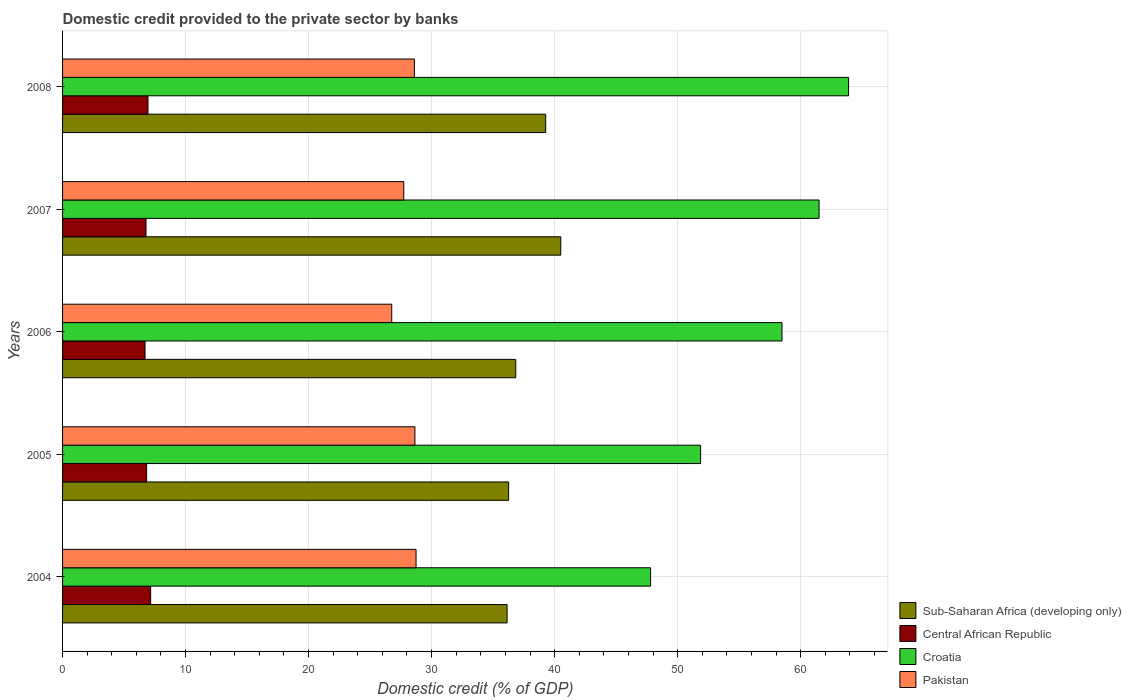How many different coloured bars are there?
Make the answer very short. 4. Are the number of bars per tick equal to the number of legend labels?
Your answer should be very brief. Yes. How many bars are there on the 3rd tick from the top?
Make the answer very short. 4. How many bars are there on the 2nd tick from the bottom?
Your response must be concise. 4. In how many cases, is the number of bars for a given year not equal to the number of legend labels?
Offer a terse response. 0. What is the domestic credit provided to the private sector by banks in Sub-Saharan Africa (developing only) in 2004?
Your answer should be compact. 36.14. Across all years, what is the maximum domestic credit provided to the private sector by banks in Pakistan?
Provide a succinct answer. 28.74. Across all years, what is the minimum domestic credit provided to the private sector by banks in Pakistan?
Offer a very short reply. 26.76. In which year was the domestic credit provided to the private sector by banks in Pakistan maximum?
Make the answer very short. 2004. What is the total domestic credit provided to the private sector by banks in Pakistan in the graph?
Ensure brevity in your answer.  140.48. What is the difference between the domestic credit provided to the private sector by banks in Sub-Saharan Africa (developing only) in 2005 and that in 2007?
Keep it short and to the point. -4.24. What is the difference between the domestic credit provided to the private sector by banks in Croatia in 2005 and the domestic credit provided to the private sector by banks in Central African Republic in 2007?
Provide a succinct answer. 45.09. What is the average domestic credit provided to the private sector by banks in Croatia per year?
Your answer should be compact. 56.71. In the year 2005, what is the difference between the domestic credit provided to the private sector by banks in Sub-Saharan Africa (developing only) and domestic credit provided to the private sector by banks in Central African Republic?
Your response must be concise. 29.43. What is the ratio of the domestic credit provided to the private sector by banks in Central African Republic in 2005 to that in 2006?
Your response must be concise. 1.02. Is the difference between the domestic credit provided to the private sector by banks in Sub-Saharan Africa (developing only) in 2005 and 2007 greater than the difference between the domestic credit provided to the private sector by banks in Central African Republic in 2005 and 2007?
Give a very brief answer. No. What is the difference between the highest and the second highest domestic credit provided to the private sector by banks in Central African Republic?
Ensure brevity in your answer.  0.22. What is the difference between the highest and the lowest domestic credit provided to the private sector by banks in Croatia?
Ensure brevity in your answer.  16.1. In how many years, is the domestic credit provided to the private sector by banks in Croatia greater than the average domestic credit provided to the private sector by banks in Croatia taken over all years?
Provide a short and direct response. 3. Is the sum of the domestic credit provided to the private sector by banks in Central African Republic in 2005 and 2008 greater than the maximum domestic credit provided to the private sector by banks in Croatia across all years?
Keep it short and to the point. No. Is it the case that in every year, the sum of the domestic credit provided to the private sector by banks in Pakistan and domestic credit provided to the private sector by banks in Central African Republic is greater than the sum of domestic credit provided to the private sector by banks in Croatia and domestic credit provided to the private sector by banks in Sub-Saharan Africa (developing only)?
Provide a succinct answer. Yes. What does the 1st bar from the top in 2008 represents?
Make the answer very short. Pakistan. What does the 4th bar from the bottom in 2006 represents?
Your answer should be very brief. Pakistan. Is it the case that in every year, the sum of the domestic credit provided to the private sector by banks in Sub-Saharan Africa (developing only) and domestic credit provided to the private sector by banks in Pakistan is greater than the domestic credit provided to the private sector by banks in Central African Republic?
Your answer should be compact. Yes. What is the difference between two consecutive major ticks on the X-axis?
Your answer should be compact. 10. Are the values on the major ticks of X-axis written in scientific E-notation?
Provide a succinct answer. No. Where does the legend appear in the graph?
Give a very brief answer. Bottom right. How are the legend labels stacked?
Ensure brevity in your answer.  Vertical. What is the title of the graph?
Your response must be concise. Domestic credit provided to the private sector by banks. What is the label or title of the X-axis?
Give a very brief answer. Domestic credit (% of GDP). What is the label or title of the Y-axis?
Ensure brevity in your answer.  Years. What is the Domestic credit (% of GDP) in Sub-Saharan Africa (developing only) in 2004?
Your answer should be compact. 36.14. What is the Domestic credit (% of GDP) in Central African Republic in 2004?
Your answer should be very brief. 7.16. What is the Domestic credit (% of GDP) of Croatia in 2004?
Ensure brevity in your answer.  47.8. What is the Domestic credit (% of GDP) in Pakistan in 2004?
Give a very brief answer. 28.74. What is the Domestic credit (% of GDP) of Sub-Saharan Africa (developing only) in 2005?
Your answer should be very brief. 36.26. What is the Domestic credit (% of GDP) of Central African Republic in 2005?
Make the answer very short. 6.83. What is the Domestic credit (% of GDP) of Croatia in 2005?
Offer a terse response. 51.87. What is the Domestic credit (% of GDP) in Pakistan in 2005?
Offer a terse response. 28.65. What is the Domestic credit (% of GDP) of Sub-Saharan Africa (developing only) in 2006?
Provide a succinct answer. 36.84. What is the Domestic credit (% of GDP) of Central African Republic in 2006?
Your answer should be compact. 6.71. What is the Domestic credit (% of GDP) in Croatia in 2006?
Offer a terse response. 58.49. What is the Domestic credit (% of GDP) in Pakistan in 2006?
Provide a short and direct response. 26.76. What is the Domestic credit (% of GDP) in Sub-Saharan Africa (developing only) in 2007?
Offer a very short reply. 40.5. What is the Domestic credit (% of GDP) of Central African Republic in 2007?
Keep it short and to the point. 6.78. What is the Domestic credit (% of GDP) in Croatia in 2007?
Offer a terse response. 61.5. What is the Domestic credit (% of GDP) of Pakistan in 2007?
Offer a very short reply. 27.74. What is the Domestic credit (% of GDP) in Sub-Saharan Africa (developing only) in 2008?
Provide a short and direct response. 39.28. What is the Domestic credit (% of GDP) of Central African Republic in 2008?
Ensure brevity in your answer.  6.94. What is the Domestic credit (% of GDP) in Croatia in 2008?
Give a very brief answer. 63.9. What is the Domestic credit (% of GDP) of Pakistan in 2008?
Provide a short and direct response. 28.6. Across all years, what is the maximum Domestic credit (% of GDP) of Sub-Saharan Africa (developing only)?
Ensure brevity in your answer.  40.5. Across all years, what is the maximum Domestic credit (% of GDP) of Central African Republic?
Offer a terse response. 7.16. Across all years, what is the maximum Domestic credit (% of GDP) of Croatia?
Ensure brevity in your answer.  63.9. Across all years, what is the maximum Domestic credit (% of GDP) of Pakistan?
Provide a succinct answer. 28.74. Across all years, what is the minimum Domestic credit (% of GDP) in Sub-Saharan Africa (developing only)?
Offer a terse response. 36.14. Across all years, what is the minimum Domestic credit (% of GDP) of Central African Republic?
Your answer should be very brief. 6.71. Across all years, what is the minimum Domestic credit (% of GDP) in Croatia?
Keep it short and to the point. 47.8. Across all years, what is the minimum Domestic credit (% of GDP) in Pakistan?
Offer a terse response. 26.76. What is the total Domestic credit (% of GDP) of Sub-Saharan Africa (developing only) in the graph?
Offer a terse response. 189.02. What is the total Domestic credit (% of GDP) of Central African Republic in the graph?
Make the answer very short. 34.43. What is the total Domestic credit (% of GDP) in Croatia in the graph?
Your answer should be compact. 283.56. What is the total Domestic credit (% of GDP) in Pakistan in the graph?
Your answer should be very brief. 140.48. What is the difference between the Domestic credit (% of GDP) of Sub-Saharan Africa (developing only) in 2004 and that in 2005?
Offer a terse response. -0.12. What is the difference between the Domestic credit (% of GDP) in Central African Republic in 2004 and that in 2005?
Give a very brief answer. 0.33. What is the difference between the Domestic credit (% of GDP) of Croatia in 2004 and that in 2005?
Provide a succinct answer. -4.06. What is the difference between the Domestic credit (% of GDP) of Pakistan in 2004 and that in 2005?
Your answer should be compact. 0.09. What is the difference between the Domestic credit (% of GDP) in Sub-Saharan Africa (developing only) in 2004 and that in 2006?
Your answer should be compact. -0.7. What is the difference between the Domestic credit (% of GDP) of Central African Republic in 2004 and that in 2006?
Make the answer very short. 0.45. What is the difference between the Domestic credit (% of GDP) in Croatia in 2004 and that in 2006?
Provide a short and direct response. -10.68. What is the difference between the Domestic credit (% of GDP) in Pakistan in 2004 and that in 2006?
Make the answer very short. 1.98. What is the difference between the Domestic credit (% of GDP) in Sub-Saharan Africa (developing only) in 2004 and that in 2007?
Your response must be concise. -4.36. What is the difference between the Domestic credit (% of GDP) in Central African Republic in 2004 and that in 2007?
Your answer should be very brief. 0.38. What is the difference between the Domestic credit (% of GDP) of Croatia in 2004 and that in 2007?
Offer a very short reply. -13.7. What is the difference between the Domestic credit (% of GDP) in Sub-Saharan Africa (developing only) in 2004 and that in 2008?
Your answer should be very brief. -3.14. What is the difference between the Domestic credit (% of GDP) of Central African Republic in 2004 and that in 2008?
Your answer should be compact. 0.22. What is the difference between the Domestic credit (% of GDP) of Croatia in 2004 and that in 2008?
Provide a succinct answer. -16.09. What is the difference between the Domestic credit (% of GDP) of Pakistan in 2004 and that in 2008?
Give a very brief answer. 0.13. What is the difference between the Domestic credit (% of GDP) of Sub-Saharan Africa (developing only) in 2005 and that in 2006?
Give a very brief answer. -0.58. What is the difference between the Domestic credit (% of GDP) in Central African Republic in 2005 and that in 2006?
Give a very brief answer. 0.13. What is the difference between the Domestic credit (% of GDP) in Croatia in 2005 and that in 2006?
Provide a succinct answer. -6.62. What is the difference between the Domestic credit (% of GDP) in Pakistan in 2005 and that in 2006?
Offer a very short reply. 1.89. What is the difference between the Domestic credit (% of GDP) of Sub-Saharan Africa (developing only) in 2005 and that in 2007?
Offer a terse response. -4.24. What is the difference between the Domestic credit (% of GDP) of Central African Republic in 2005 and that in 2007?
Give a very brief answer. 0.05. What is the difference between the Domestic credit (% of GDP) of Croatia in 2005 and that in 2007?
Provide a succinct answer. -9.63. What is the difference between the Domestic credit (% of GDP) of Pakistan in 2005 and that in 2007?
Make the answer very short. 0.91. What is the difference between the Domestic credit (% of GDP) of Sub-Saharan Africa (developing only) in 2005 and that in 2008?
Your response must be concise. -3.01. What is the difference between the Domestic credit (% of GDP) in Central African Republic in 2005 and that in 2008?
Give a very brief answer. -0.11. What is the difference between the Domestic credit (% of GDP) of Croatia in 2005 and that in 2008?
Your answer should be compact. -12.03. What is the difference between the Domestic credit (% of GDP) of Pakistan in 2005 and that in 2008?
Your response must be concise. 0.04. What is the difference between the Domestic credit (% of GDP) in Sub-Saharan Africa (developing only) in 2006 and that in 2007?
Offer a very short reply. -3.66. What is the difference between the Domestic credit (% of GDP) of Central African Republic in 2006 and that in 2007?
Offer a terse response. -0.08. What is the difference between the Domestic credit (% of GDP) of Croatia in 2006 and that in 2007?
Give a very brief answer. -3.01. What is the difference between the Domestic credit (% of GDP) in Pakistan in 2006 and that in 2007?
Keep it short and to the point. -0.98. What is the difference between the Domestic credit (% of GDP) in Sub-Saharan Africa (developing only) in 2006 and that in 2008?
Your answer should be compact. -2.43. What is the difference between the Domestic credit (% of GDP) of Central African Republic in 2006 and that in 2008?
Offer a very short reply. -0.24. What is the difference between the Domestic credit (% of GDP) in Croatia in 2006 and that in 2008?
Your answer should be very brief. -5.41. What is the difference between the Domestic credit (% of GDP) in Pakistan in 2006 and that in 2008?
Provide a short and direct response. -1.84. What is the difference between the Domestic credit (% of GDP) of Sub-Saharan Africa (developing only) in 2007 and that in 2008?
Provide a short and direct response. 1.23. What is the difference between the Domestic credit (% of GDP) in Central African Republic in 2007 and that in 2008?
Provide a succinct answer. -0.16. What is the difference between the Domestic credit (% of GDP) of Croatia in 2007 and that in 2008?
Provide a short and direct response. -2.4. What is the difference between the Domestic credit (% of GDP) of Pakistan in 2007 and that in 2008?
Make the answer very short. -0.87. What is the difference between the Domestic credit (% of GDP) in Sub-Saharan Africa (developing only) in 2004 and the Domestic credit (% of GDP) in Central African Republic in 2005?
Offer a very short reply. 29.31. What is the difference between the Domestic credit (% of GDP) in Sub-Saharan Africa (developing only) in 2004 and the Domestic credit (% of GDP) in Croatia in 2005?
Your answer should be very brief. -15.73. What is the difference between the Domestic credit (% of GDP) in Sub-Saharan Africa (developing only) in 2004 and the Domestic credit (% of GDP) in Pakistan in 2005?
Offer a terse response. 7.49. What is the difference between the Domestic credit (% of GDP) of Central African Republic in 2004 and the Domestic credit (% of GDP) of Croatia in 2005?
Ensure brevity in your answer.  -44.71. What is the difference between the Domestic credit (% of GDP) of Central African Republic in 2004 and the Domestic credit (% of GDP) of Pakistan in 2005?
Make the answer very short. -21.48. What is the difference between the Domestic credit (% of GDP) in Croatia in 2004 and the Domestic credit (% of GDP) in Pakistan in 2005?
Provide a short and direct response. 19.16. What is the difference between the Domestic credit (% of GDP) in Sub-Saharan Africa (developing only) in 2004 and the Domestic credit (% of GDP) in Central African Republic in 2006?
Your answer should be compact. 29.43. What is the difference between the Domestic credit (% of GDP) in Sub-Saharan Africa (developing only) in 2004 and the Domestic credit (% of GDP) in Croatia in 2006?
Your response must be concise. -22.35. What is the difference between the Domestic credit (% of GDP) in Sub-Saharan Africa (developing only) in 2004 and the Domestic credit (% of GDP) in Pakistan in 2006?
Provide a short and direct response. 9.38. What is the difference between the Domestic credit (% of GDP) in Central African Republic in 2004 and the Domestic credit (% of GDP) in Croatia in 2006?
Ensure brevity in your answer.  -51.33. What is the difference between the Domestic credit (% of GDP) in Central African Republic in 2004 and the Domestic credit (% of GDP) in Pakistan in 2006?
Provide a short and direct response. -19.6. What is the difference between the Domestic credit (% of GDP) of Croatia in 2004 and the Domestic credit (% of GDP) of Pakistan in 2006?
Provide a short and direct response. 21.04. What is the difference between the Domestic credit (% of GDP) of Sub-Saharan Africa (developing only) in 2004 and the Domestic credit (% of GDP) of Central African Republic in 2007?
Offer a very short reply. 29.36. What is the difference between the Domestic credit (% of GDP) in Sub-Saharan Africa (developing only) in 2004 and the Domestic credit (% of GDP) in Croatia in 2007?
Your answer should be compact. -25.36. What is the difference between the Domestic credit (% of GDP) of Sub-Saharan Africa (developing only) in 2004 and the Domestic credit (% of GDP) of Pakistan in 2007?
Your answer should be very brief. 8.4. What is the difference between the Domestic credit (% of GDP) of Central African Republic in 2004 and the Domestic credit (% of GDP) of Croatia in 2007?
Keep it short and to the point. -54.34. What is the difference between the Domestic credit (% of GDP) in Central African Republic in 2004 and the Domestic credit (% of GDP) in Pakistan in 2007?
Your response must be concise. -20.58. What is the difference between the Domestic credit (% of GDP) in Croatia in 2004 and the Domestic credit (% of GDP) in Pakistan in 2007?
Your answer should be very brief. 20.07. What is the difference between the Domestic credit (% of GDP) in Sub-Saharan Africa (developing only) in 2004 and the Domestic credit (% of GDP) in Central African Republic in 2008?
Ensure brevity in your answer.  29.19. What is the difference between the Domestic credit (% of GDP) in Sub-Saharan Africa (developing only) in 2004 and the Domestic credit (% of GDP) in Croatia in 2008?
Keep it short and to the point. -27.76. What is the difference between the Domestic credit (% of GDP) in Sub-Saharan Africa (developing only) in 2004 and the Domestic credit (% of GDP) in Pakistan in 2008?
Provide a succinct answer. 7.54. What is the difference between the Domestic credit (% of GDP) in Central African Republic in 2004 and the Domestic credit (% of GDP) in Croatia in 2008?
Provide a short and direct response. -56.74. What is the difference between the Domestic credit (% of GDP) in Central African Republic in 2004 and the Domestic credit (% of GDP) in Pakistan in 2008?
Offer a very short reply. -21.44. What is the difference between the Domestic credit (% of GDP) of Croatia in 2004 and the Domestic credit (% of GDP) of Pakistan in 2008?
Offer a terse response. 19.2. What is the difference between the Domestic credit (% of GDP) of Sub-Saharan Africa (developing only) in 2005 and the Domestic credit (% of GDP) of Central African Republic in 2006?
Give a very brief answer. 29.56. What is the difference between the Domestic credit (% of GDP) in Sub-Saharan Africa (developing only) in 2005 and the Domestic credit (% of GDP) in Croatia in 2006?
Ensure brevity in your answer.  -22.22. What is the difference between the Domestic credit (% of GDP) of Sub-Saharan Africa (developing only) in 2005 and the Domestic credit (% of GDP) of Pakistan in 2006?
Your answer should be very brief. 9.5. What is the difference between the Domestic credit (% of GDP) of Central African Republic in 2005 and the Domestic credit (% of GDP) of Croatia in 2006?
Give a very brief answer. -51.65. What is the difference between the Domestic credit (% of GDP) in Central African Republic in 2005 and the Domestic credit (% of GDP) in Pakistan in 2006?
Your answer should be very brief. -19.93. What is the difference between the Domestic credit (% of GDP) in Croatia in 2005 and the Domestic credit (% of GDP) in Pakistan in 2006?
Make the answer very short. 25.11. What is the difference between the Domestic credit (% of GDP) of Sub-Saharan Africa (developing only) in 2005 and the Domestic credit (% of GDP) of Central African Republic in 2007?
Offer a terse response. 29.48. What is the difference between the Domestic credit (% of GDP) in Sub-Saharan Africa (developing only) in 2005 and the Domestic credit (% of GDP) in Croatia in 2007?
Ensure brevity in your answer.  -25.24. What is the difference between the Domestic credit (% of GDP) in Sub-Saharan Africa (developing only) in 2005 and the Domestic credit (% of GDP) in Pakistan in 2007?
Your answer should be compact. 8.53. What is the difference between the Domestic credit (% of GDP) in Central African Republic in 2005 and the Domestic credit (% of GDP) in Croatia in 2007?
Give a very brief answer. -54.67. What is the difference between the Domestic credit (% of GDP) of Central African Republic in 2005 and the Domestic credit (% of GDP) of Pakistan in 2007?
Make the answer very short. -20.9. What is the difference between the Domestic credit (% of GDP) in Croatia in 2005 and the Domestic credit (% of GDP) in Pakistan in 2007?
Make the answer very short. 24.13. What is the difference between the Domestic credit (% of GDP) of Sub-Saharan Africa (developing only) in 2005 and the Domestic credit (% of GDP) of Central African Republic in 2008?
Ensure brevity in your answer.  29.32. What is the difference between the Domestic credit (% of GDP) of Sub-Saharan Africa (developing only) in 2005 and the Domestic credit (% of GDP) of Croatia in 2008?
Give a very brief answer. -27.64. What is the difference between the Domestic credit (% of GDP) of Sub-Saharan Africa (developing only) in 2005 and the Domestic credit (% of GDP) of Pakistan in 2008?
Your answer should be compact. 7.66. What is the difference between the Domestic credit (% of GDP) of Central African Republic in 2005 and the Domestic credit (% of GDP) of Croatia in 2008?
Offer a terse response. -57.07. What is the difference between the Domestic credit (% of GDP) in Central African Republic in 2005 and the Domestic credit (% of GDP) in Pakistan in 2008?
Your answer should be very brief. -21.77. What is the difference between the Domestic credit (% of GDP) of Croatia in 2005 and the Domestic credit (% of GDP) of Pakistan in 2008?
Keep it short and to the point. 23.27. What is the difference between the Domestic credit (% of GDP) in Sub-Saharan Africa (developing only) in 2006 and the Domestic credit (% of GDP) in Central African Republic in 2007?
Ensure brevity in your answer.  30.06. What is the difference between the Domestic credit (% of GDP) of Sub-Saharan Africa (developing only) in 2006 and the Domestic credit (% of GDP) of Croatia in 2007?
Your answer should be compact. -24.66. What is the difference between the Domestic credit (% of GDP) of Sub-Saharan Africa (developing only) in 2006 and the Domestic credit (% of GDP) of Pakistan in 2007?
Ensure brevity in your answer.  9.11. What is the difference between the Domestic credit (% of GDP) of Central African Republic in 2006 and the Domestic credit (% of GDP) of Croatia in 2007?
Your answer should be very brief. -54.79. What is the difference between the Domestic credit (% of GDP) in Central African Republic in 2006 and the Domestic credit (% of GDP) in Pakistan in 2007?
Your answer should be very brief. -21.03. What is the difference between the Domestic credit (% of GDP) of Croatia in 2006 and the Domestic credit (% of GDP) of Pakistan in 2007?
Ensure brevity in your answer.  30.75. What is the difference between the Domestic credit (% of GDP) in Sub-Saharan Africa (developing only) in 2006 and the Domestic credit (% of GDP) in Central African Republic in 2008?
Provide a succinct answer. 29.9. What is the difference between the Domestic credit (% of GDP) of Sub-Saharan Africa (developing only) in 2006 and the Domestic credit (% of GDP) of Croatia in 2008?
Your answer should be compact. -27.06. What is the difference between the Domestic credit (% of GDP) in Sub-Saharan Africa (developing only) in 2006 and the Domestic credit (% of GDP) in Pakistan in 2008?
Keep it short and to the point. 8.24. What is the difference between the Domestic credit (% of GDP) of Central African Republic in 2006 and the Domestic credit (% of GDP) of Croatia in 2008?
Your response must be concise. -57.19. What is the difference between the Domestic credit (% of GDP) in Central African Republic in 2006 and the Domestic credit (% of GDP) in Pakistan in 2008?
Ensure brevity in your answer.  -21.9. What is the difference between the Domestic credit (% of GDP) in Croatia in 2006 and the Domestic credit (% of GDP) in Pakistan in 2008?
Offer a terse response. 29.88. What is the difference between the Domestic credit (% of GDP) of Sub-Saharan Africa (developing only) in 2007 and the Domestic credit (% of GDP) of Central African Republic in 2008?
Provide a succinct answer. 33.56. What is the difference between the Domestic credit (% of GDP) in Sub-Saharan Africa (developing only) in 2007 and the Domestic credit (% of GDP) in Croatia in 2008?
Make the answer very short. -23.4. What is the difference between the Domestic credit (% of GDP) in Sub-Saharan Africa (developing only) in 2007 and the Domestic credit (% of GDP) in Pakistan in 2008?
Offer a terse response. 11.9. What is the difference between the Domestic credit (% of GDP) in Central African Republic in 2007 and the Domestic credit (% of GDP) in Croatia in 2008?
Offer a very short reply. -57.12. What is the difference between the Domestic credit (% of GDP) in Central African Republic in 2007 and the Domestic credit (% of GDP) in Pakistan in 2008?
Ensure brevity in your answer.  -21.82. What is the difference between the Domestic credit (% of GDP) in Croatia in 2007 and the Domestic credit (% of GDP) in Pakistan in 2008?
Provide a short and direct response. 32.9. What is the average Domestic credit (% of GDP) in Sub-Saharan Africa (developing only) per year?
Offer a terse response. 37.8. What is the average Domestic credit (% of GDP) in Central African Republic per year?
Give a very brief answer. 6.89. What is the average Domestic credit (% of GDP) of Croatia per year?
Ensure brevity in your answer.  56.71. What is the average Domestic credit (% of GDP) of Pakistan per year?
Provide a short and direct response. 28.1. In the year 2004, what is the difference between the Domestic credit (% of GDP) in Sub-Saharan Africa (developing only) and Domestic credit (% of GDP) in Central African Republic?
Provide a succinct answer. 28.98. In the year 2004, what is the difference between the Domestic credit (% of GDP) in Sub-Saharan Africa (developing only) and Domestic credit (% of GDP) in Croatia?
Provide a short and direct response. -11.67. In the year 2004, what is the difference between the Domestic credit (% of GDP) of Sub-Saharan Africa (developing only) and Domestic credit (% of GDP) of Pakistan?
Provide a succinct answer. 7.4. In the year 2004, what is the difference between the Domestic credit (% of GDP) in Central African Republic and Domestic credit (% of GDP) in Croatia?
Your answer should be compact. -40.64. In the year 2004, what is the difference between the Domestic credit (% of GDP) of Central African Republic and Domestic credit (% of GDP) of Pakistan?
Keep it short and to the point. -21.58. In the year 2004, what is the difference between the Domestic credit (% of GDP) of Croatia and Domestic credit (% of GDP) of Pakistan?
Your response must be concise. 19.07. In the year 2005, what is the difference between the Domestic credit (% of GDP) of Sub-Saharan Africa (developing only) and Domestic credit (% of GDP) of Central African Republic?
Your answer should be compact. 29.43. In the year 2005, what is the difference between the Domestic credit (% of GDP) in Sub-Saharan Africa (developing only) and Domestic credit (% of GDP) in Croatia?
Offer a terse response. -15.61. In the year 2005, what is the difference between the Domestic credit (% of GDP) of Sub-Saharan Africa (developing only) and Domestic credit (% of GDP) of Pakistan?
Offer a terse response. 7.62. In the year 2005, what is the difference between the Domestic credit (% of GDP) of Central African Republic and Domestic credit (% of GDP) of Croatia?
Your answer should be compact. -45.04. In the year 2005, what is the difference between the Domestic credit (% of GDP) of Central African Republic and Domestic credit (% of GDP) of Pakistan?
Provide a succinct answer. -21.81. In the year 2005, what is the difference between the Domestic credit (% of GDP) in Croatia and Domestic credit (% of GDP) in Pakistan?
Your response must be concise. 23.22. In the year 2006, what is the difference between the Domestic credit (% of GDP) in Sub-Saharan Africa (developing only) and Domestic credit (% of GDP) in Central African Republic?
Make the answer very short. 30.14. In the year 2006, what is the difference between the Domestic credit (% of GDP) in Sub-Saharan Africa (developing only) and Domestic credit (% of GDP) in Croatia?
Your response must be concise. -21.64. In the year 2006, what is the difference between the Domestic credit (% of GDP) in Sub-Saharan Africa (developing only) and Domestic credit (% of GDP) in Pakistan?
Your answer should be very brief. 10.08. In the year 2006, what is the difference between the Domestic credit (% of GDP) of Central African Republic and Domestic credit (% of GDP) of Croatia?
Offer a very short reply. -51.78. In the year 2006, what is the difference between the Domestic credit (% of GDP) of Central African Republic and Domestic credit (% of GDP) of Pakistan?
Keep it short and to the point. -20.05. In the year 2006, what is the difference between the Domestic credit (% of GDP) of Croatia and Domestic credit (% of GDP) of Pakistan?
Provide a succinct answer. 31.73. In the year 2007, what is the difference between the Domestic credit (% of GDP) in Sub-Saharan Africa (developing only) and Domestic credit (% of GDP) in Central African Republic?
Provide a short and direct response. 33.72. In the year 2007, what is the difference between the Domestic credit (% of GDP) in Sub-Saharan Africa (developing only) and Domestic credit (% of GDP) in Croatia?
Offer a terse response. -21. In the year 2007, what is the difference between the Domestic credit (% of GDP) in Sub-Saharan Africa (developing only) and Domestic credit (% of GDP) in Pakistan?
Make the answer very short. 12.77. In the year 2007, what is the difference between the Domestic credit (% of GDP) in Central African Republic and Domestic credit (% of GDP) in Croatia?
Your response must be concise. -54.72. In the year 2007, what is the difference between the Domestic credit (% of GDP) of Central African Republic and Domestic credit (% of GDP) of Pakistan?
Keep it short and to the point. -20.95. In the year 2007, what is the difference between the Domestic credit (% of GDP) of Croatia and Domestic credit (% of GDP) of Pakistan?
Provide a short and direct response. 33.76. In the year 2008, what is the difference between the Domestic credit (% of GDP) in Sub-Saharan Africa (developing only) and Domestic credit (% of GDP) in Central African Republic?
Provide a succinct answer. 32.33. In the year 2008, what is the difference between the Domestic credit (% of GDP) in Sub-Saharan Africa (developing only) and Domestic credit (% of GDP) in Croatia?
Give a very brief answer. -24.62. In the year 2008, what is the difference between the Domestic credit (% of GDP) in Sub-Saharan Africa (developing only) and Domestic credit (% of GDP) in Pakistan?
Give a very brief answer. 10.67. In the year 2008, what is the difference between the Domestic credit (% of GDP) in Central African Republic and Domestic credit (% of GDP) in Croatia?
Your response must be concise. -56.96. In the year 2008, what is the difference between the Domestic credit (% of GDP) in Central African Republic and Domestic credit (% of GDP) in Pakistan?
Ensure brevity in your answer.  -21.66. In the year 2008, what is the difference between the Domestic credit (% of GDP) in Croatia and Domestic credit (% of GDP) in Pakistan?
Offer a terse response. 35.3. What is the ratio of the Domestic credit (% of GDP) in Central African Republic in 2004 to that in 2005?
Keep it short and to the point. 1.05. What is the ratio of the Domestic credit (% of GDP) in Croatia in 2004 to that in 2005?
Your answer should be compact. 0.92. What is the ratio of the Domestic credit (% of GDP) in Pakistan in 2004 to that in 2005?
Offer a very short reply. 1. What is the ratio of the Domestic credit (% of GDP) of Sub-Saharan Africa (developing only) in 2004 to that in 2006?
Provide a succinct answer. 0.98. What is the ratio of the Domestic credit (% of GDP) of Central African Republic in 2004 to that in 2006?
Provide a succinct answer. 1.07. What is the ratio of the Domestic credit (% of GDP) in Croatia in 2004 to that in 2006?
Your answer should be very brief. 0.82. What is the ratio of the Domestic credit (% of GDP) in Pakistan in 2004 to that in 2006?
Your response must be concise. 1.07. What is the ratio of the Domestic credit (% of GDP) in Sub-Saharan Africa (developing only) in 2004 to that in 2007?
Give a very brief answer. 0.89. What is the ratio of the Domestic credit (% of GDP) in Central African Republic in 2004 to that in 2007?
Give a very brief answer. 1.06. What is the ratio of the Domestic credit (% of GDP) of Croatia in 2004 to that in 2007?
Keep it short and to the point. 0.78. What is the ratio of the Domestic credit (% of GDP) in Pakistan in 2004 to that in 2007?
Your response must be concise. 1.04. What is the ratio of the Domestic credit (% of GDP) of Sub-Saharan Africa (developing only) in 2004 to that in 2008?
Your response must be concise. 0.92. What is the ratio of the Domestic credit (% of GDP) in Central African Republic in 2004 to that in 2008?
Keep it short and to the point. 1.03. What is the ratio of the Domestic credit (% of GDP) in Croatia in 2004 to that in 2008?
Provide a short and direct response. 0.75. What is the ratio of the Domestic credit (% of GDP) of Sub-Saharan Africa (developing only) in 2005 to that in 2006?
Make the answer very short. 0.98. What is the ratio of the Domestic credit (% of GDP) in Central African Republic in 2005 to that in 2006?
Your response must be concise. 1.02. What is the ratio of the Domestic credit (% of GDP) of Croatia in 2005 to that in 2006?
Offer a very short reply. 0.89. What is the ratio of the Domestic credit (% of GDP) of Pakistan in 2005 to that in 2006?
Make the answer very short. 1.07. What is the ratio of the Domestic credit (% of GDP) of Sub-Saharan Africa (developing only) in 2005 to that in 2007?
Your answer should be compact. 0.9. What is the ratio of the Domestic credit (% of GDP) of Central African Republic in 2005 to that in 2007?
Keep it short and to the point. 1.01. What is the ratio of the Domestic credit (% of GDP) of Croatia in 2005 to that in 2007?
Keep it short and to the point. 0.84. What is the ratio of the Domestic credit (% of GDP) of Pakistan in 2005 to that in 2007?
Your answer should be very brief. 1.03. What is the ratio of the Domestic credit (% of GDP) of Sub-Saharan Africa (developing only) in 2005 to that in 2008?
Your answer should be compact. 0.92. What is the ratio of the Domestic credit (% of GDP) in Croatia in 2005 to that in 2008?
Your response must be concise. 0.81. What is the ratio of the Domestic credit (% of GDP) of Pakistan in 2005 to that in 2008?
Provide a short and direct response. 1. What is the ratio of the Domestic credit (% of GDP) in Sub-Saharan Africa (developing only) in 2006 to that in 2007?
Your response must be concise. 0.91. What is the ratio of the Domestic credit (% of GDP) of Croatia in 2006 to that in 2007?
Offer a terse response. 0.95. What is the ratio of the Domestic credit (% of GDP) in Pakistan in 2006 to that in 2007?
Make the answer very short. 0.96. What is the ratio of the Domestic credit (% of GDP) in Sub-Saharan Africa (developing only) in 2006 to that in 2008?
Make the answer very short. 0.94. What is the ratio of the Domestic credit (% of GDP) in Central African Republic in 2006 to that in 2008?
Keep it short and to the point. 0.97. What is the ratio of the Domestic credit (% of GDP) in Croatia in 2006 to that in 2008?
Give a very brief answer. 0.92. What is the ratio of the Domestic credit (% of GDP) of Pakistan in 2006 to that in 2008?
Make the answer very short. 0.94. What is the ratio of the Domestic credit (% of GDP) in Sub-Saharan Africa (developing only) in 2007 to that in 2008?
Provide a short and direct response. 1.03. What is the ratio of the Domestic credit (% of GDP) in Central African Republic in 2007 to that in 2008?
Your response must be concise. 0.98. What is the ratio of the Domestic credit (% of GDP) of Croatia in 2007 to that in 2008?
Provide a succinct answer. 0.96. What is the ratio of the Domestic credit (% of GDP) in Pakistan in 2007 to that in 2008?
Keep it short and to the point. 0.97. What is the difference between the highest and the second highest Domestic credit (% of GDP) in Sub-Saharan Africa (developing only)?
Offer a very short reply. 1.23. What is the difference between the highest and the second highest Domestic credit (% of GDP) of Central African Republic?
Your response must be concise. 0.22. What is the difference between the highest and the second highest Domestic credit (% of GDP) in Croatia?
Provide a succinct answer. 2.4. What is the difference between the highest and the second highest Domestic credit (% of GDP) of Pakistan?
Keep it short and to the point. 0.09. What is the difference between the highest and the lowest Domestic credit (% of GDP) in Sub-Saharan Africa (developing only)?
Your answer should be very brief. 4.36. What is the difference between the highest and the lowest Domestic credit (% of GDP) in Central African Republic?
Provide a short and direct response. 0.45. What is the difference between the highest and the lowest Domestic credit (% of GDP) in Croatia?
Provide a short and direct response. 16.09. What is the difference between the highest and the lowest Domestic credit (% of GDP) of Pakistan?
Provide a succinct answer. 1.98. 